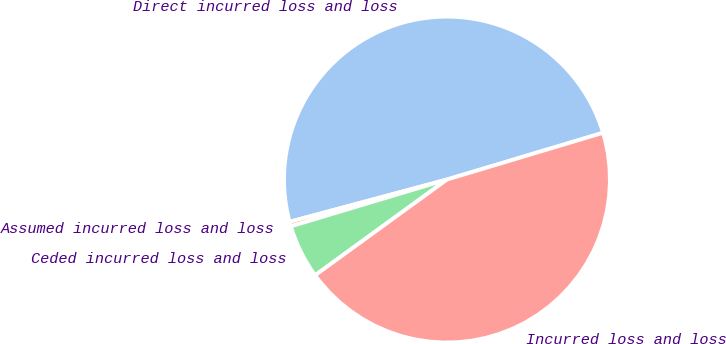Convert chart to OTSL. <chart><loc_0><loc_0><loc_500><loc_500><pie_chart><fcel>Direct incurred loss and loss<fcel>Assumed incurred loss and loss<fcel>Ceded incurred loss and loss<fcel>Incurred loss and loss<nl><fcel>49.54%<fcel>0.46%<fcel>5.36%<fcel>44.64%<nl></chart> 